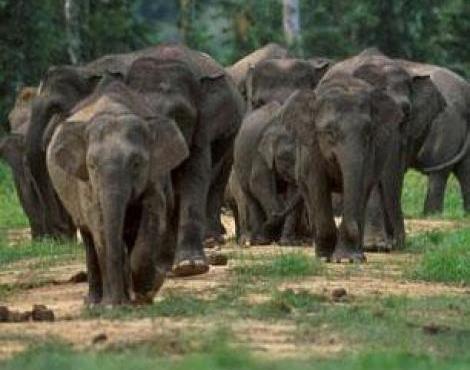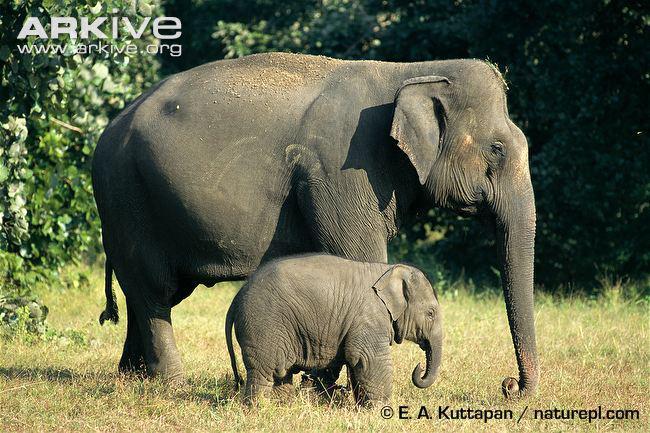The first image is the image on the left, the second image is the image on the right. Examine the images to the left and right. Is the description "One image has only one elephant in it." accurate? Answer yes or no. No. 